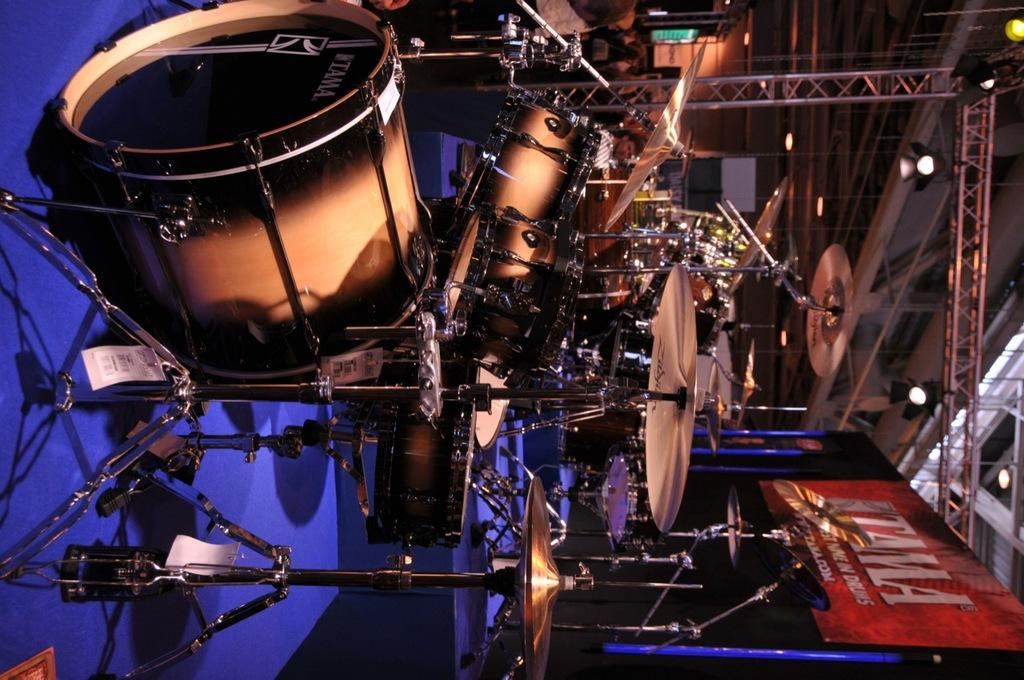What musical instruments are present in the image? There are drum sets in the image. What is the color of the mat on which the drum sets are placed? The drum sets are on a blue color mat. What can be seen on the right side of the image? There is a banner on the right side of the image. What type of lighting is present in the image? There are lights in the image. What type of structure is visible in the image? There are iron frames in the image. What electronic device is present at the top of the image? There is a television screen at the top of the image. What type of alley can be seen behind the drum sets in the image? There is no alley visible in the image; it is focused on the drum sets, banner, lights, iron frames, and television screen. 